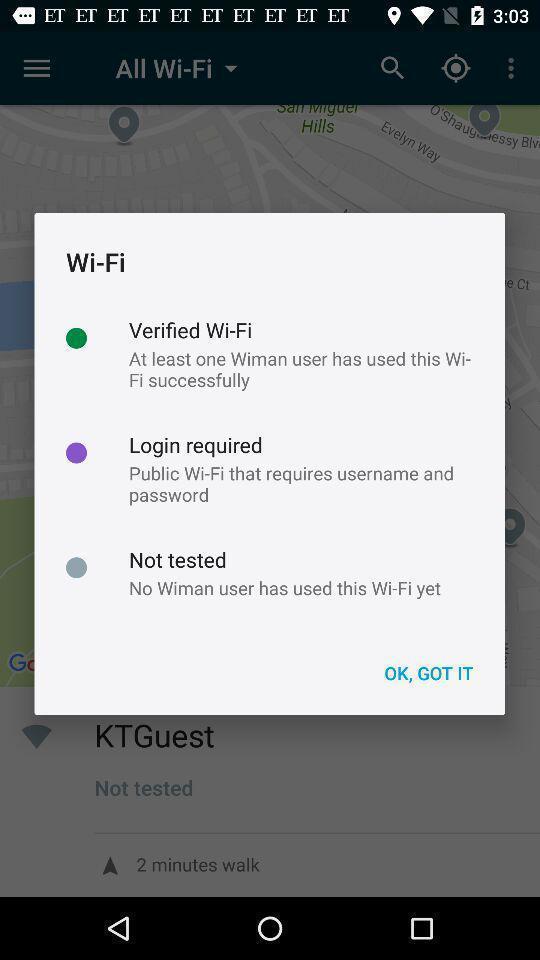Summarize the main components in this picture. Pop-up displaying information about wi-fi. 